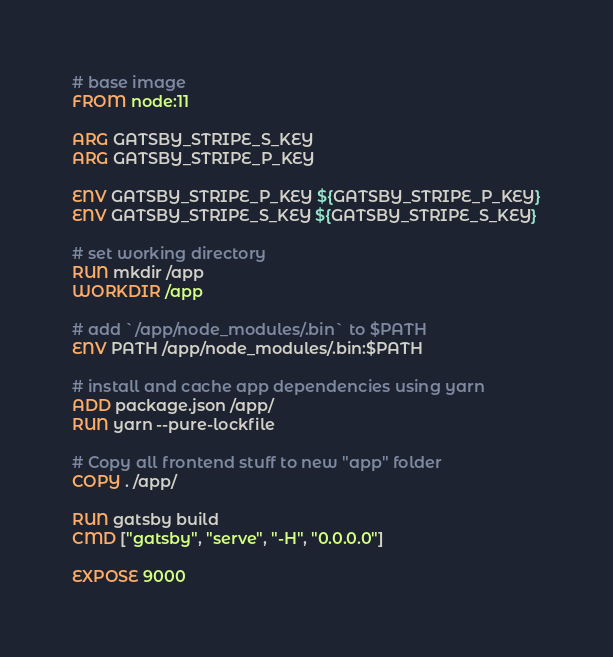Convert code to text. <code><loc_0><loc_0><loc_500><loc_500><_Dockerfile_># base image
FROM node:11

ARG GATSBY_STRIPE_S_KEY
ARG GATSBY_STRIPE_P_KEY

ENV GATSBY_STRIPE_P_KEY ${GATSBY_STRIPE_P_KEY}
ENV GATSBY_STRIPE_S_KEY ${GATSBY_STRIPE_S_KEY}

# set working directory
RUN mkdir /app
WORKDIR /app

# add `/app/node_modules/.bin` to $PATH
ENV PATH /app/node_modules/.bin:$PATH

# install and cache app dependencies using yarn
ADD package.json /app/
RUN yarn --pure-lockfile

# Copy all frontend stuff to new "app" folder
COPY . /app/

RUN gatsby build
CMD ["gatsby", "serve", "-H", "0.0.0.0"]

EXPOSE 9000</code> 